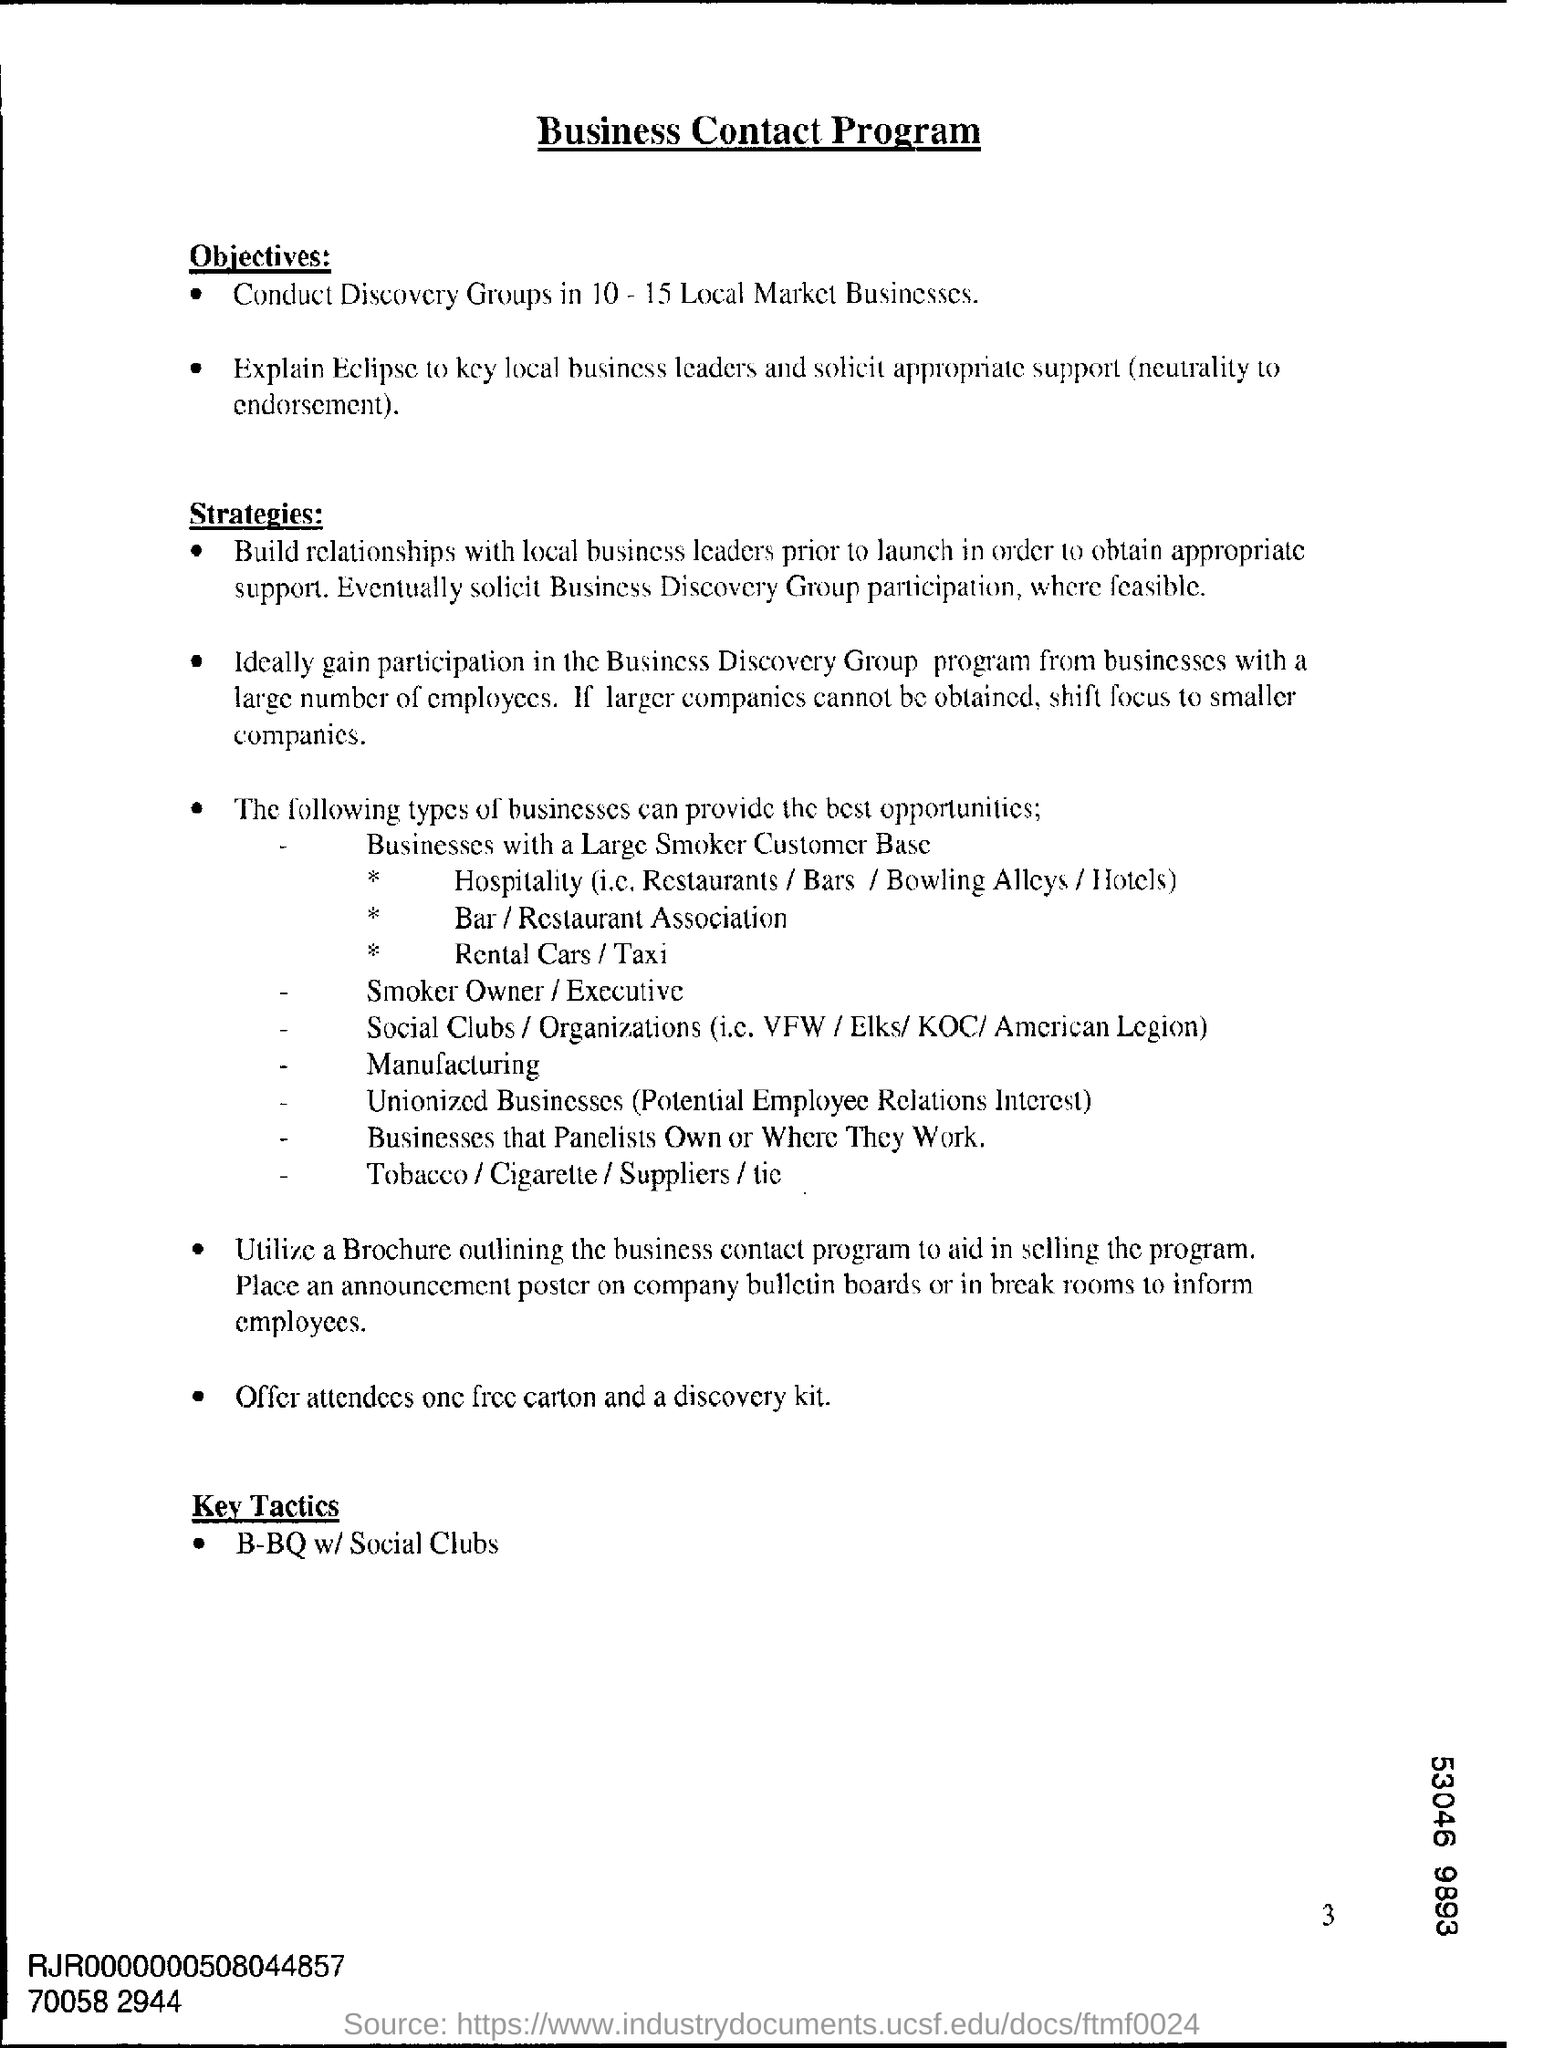Point out several critical features in this image. The third heading of the document is entitled 'Key Tactics'. The primary goal of the Business Contact Program is to conduct Discovery Groups in approximately 10-15 local market businesses in order to gain a deeper understanding of their unique challenges and opportunities. We will offer attendees one free carton and a discovery kit as our last strategy to encourage them to make a purchase. 